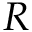<formula> <loc_0><loc_0><loc_500><loc_500>R</formula> 